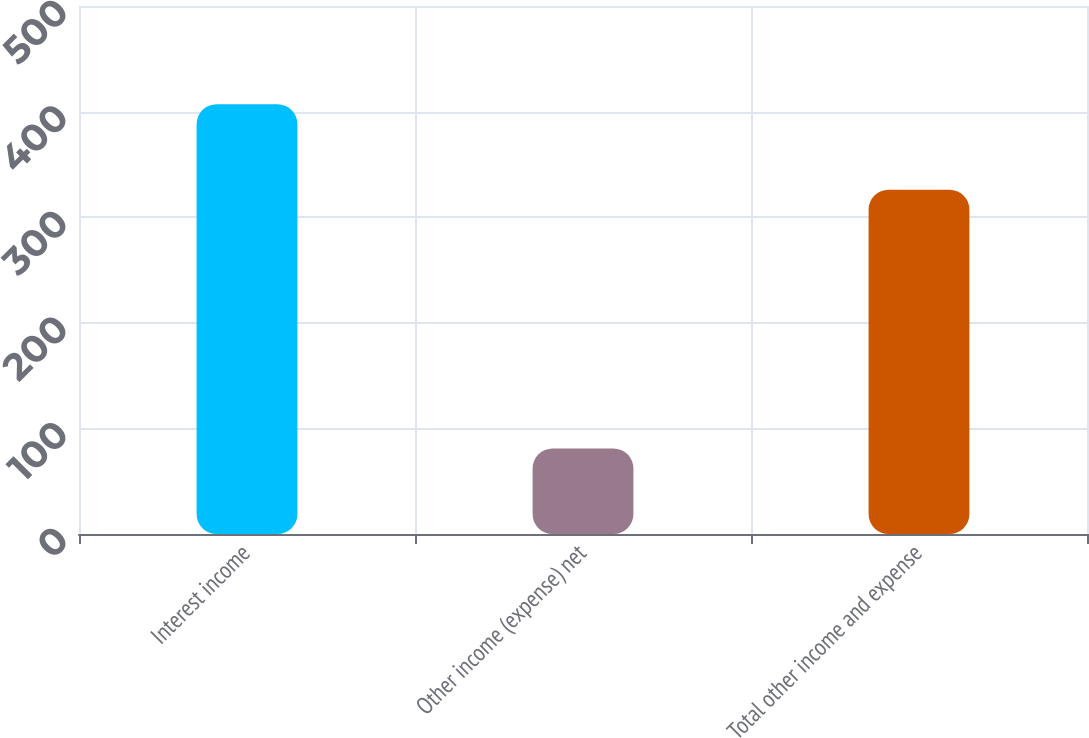Convert chart to OTSL. <chart><loc_0><loc_0><loc_500><loc_500><bar_chart><fcel>Interest income<fcel>Other income (expense) net<fcel>Total other income and expense<nl><fcel>407<fcel>81<fcel>326<nl></chart> 